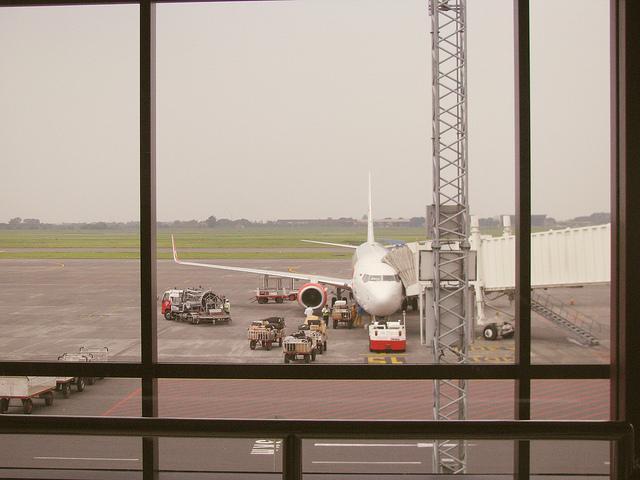How many planes are there?
Give a very brief answer. 1. 